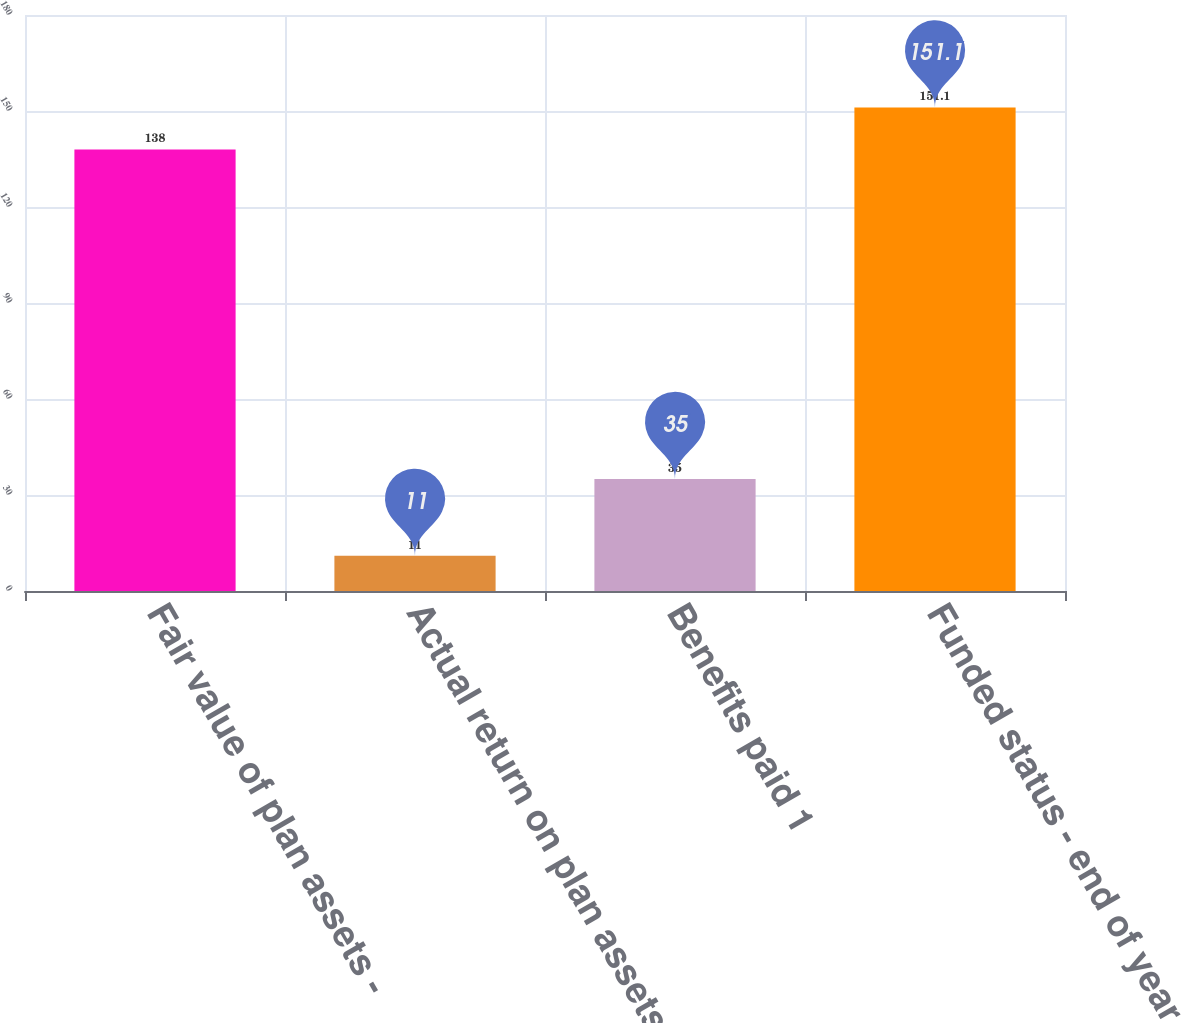Convert chart. <chart><loc_0><loc_0><loc_500><loc_500><bar_chart><fcel>Fair value of plan assets -<fcel>Actual return on plan assets<fcel>Benefits paid 1<fcel>Funded status - end of year<nl><fcel>138<fcel>11<fcel>35<fcel>151.1<nl></chart> 